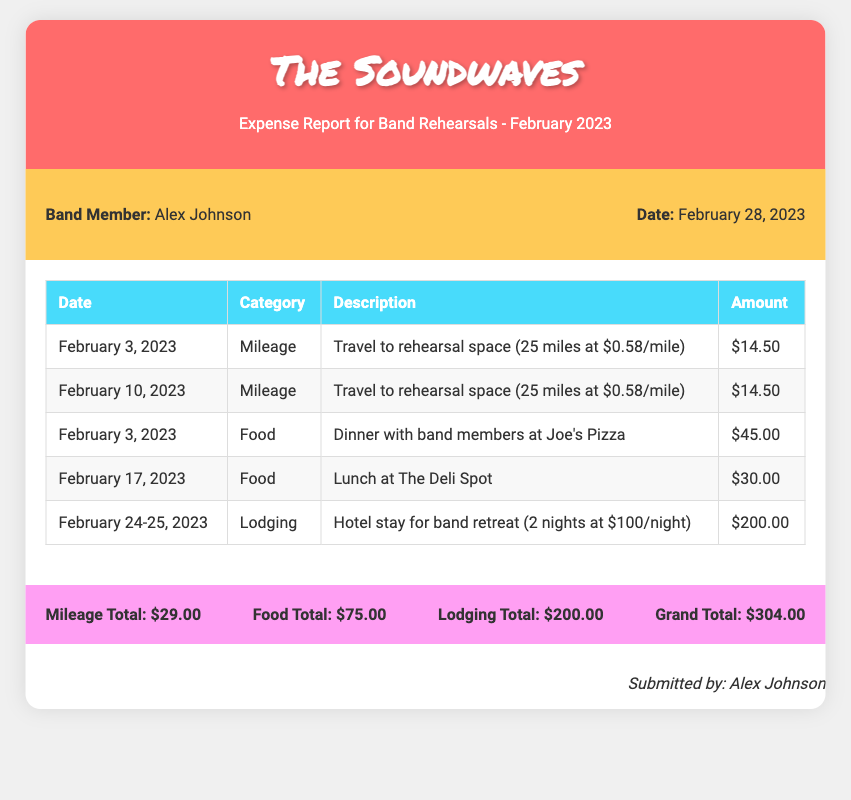what is the name of the band? The band's name is mentioned in the header of the document as "The Soundwaves."
Answer: The Soundwaves who submitted the expense report? The expense report was submitted by Alex Johnson, as indicated in the signature section.
Answer: Alex Johnson how much was spent on lodging? The lodging expenses are listed in the table as totaling $200.00 for hotel stay over two nights.
Answer: $200.00 what was the total food expense? The total food expenses can be calculated from the provided food entries, which sum up to $75.00.
Answer: $75.00 how many miles were traveled for rehearsals? The mileage entries indicate two trips of 25 miles each, totaling 50 miles.
Answer: 50 miles what is the grand total of all expenses? The grand total is specifically mentioned at the bottom of the document, which totals $304.00.
Answer: $304.00 on which date was the hotel stay for the band retreat? The hotel stay occurred from February 24-25, 2023, as noted in the lodging entry.
Answer: February 24-25, 2023 how much was each night of the hotel stay? The cost per night for the hotel stay is provided as $100, which is mentioned in the lodging description.
Answer: $100 what type of meal was had at Joe's Pizza? The document states that it was dinner with band members at Joe's Pizza, indicated in the food expense section.
Answer: Dinner 